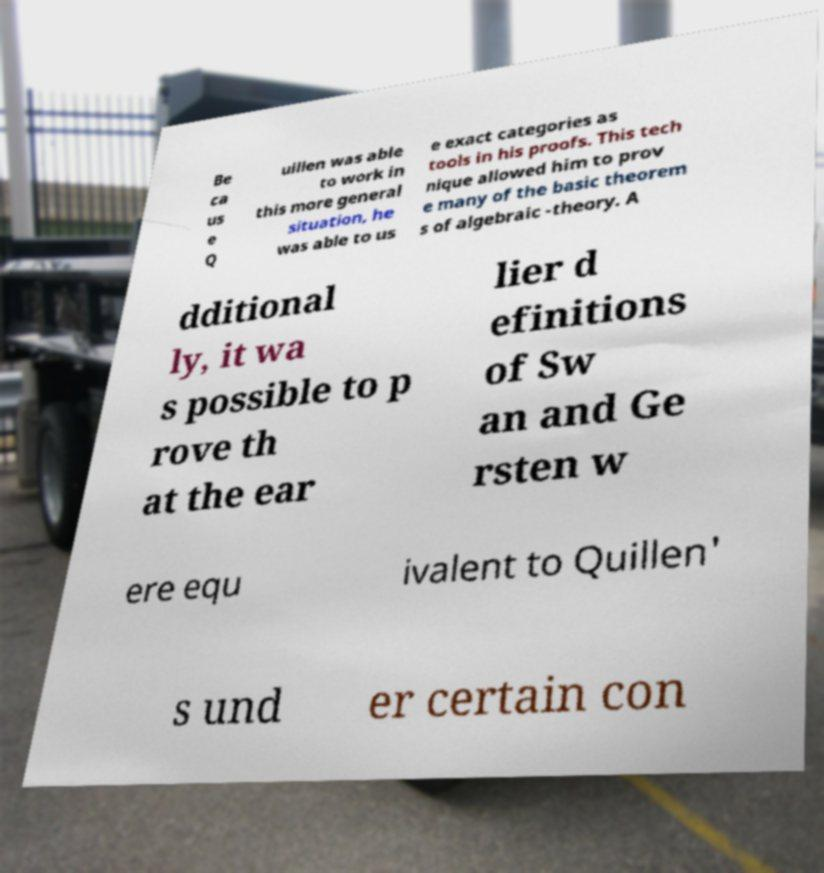Please identify and transcribe the text found in this image. Be ca us e Q uillen was able to work in this more general situation, he was able to us e exact categories as tools in his proofs. This tech nique allowed him to prov e many of the basic theorem s of algebraic -theory. A dditional ly, it wa s possible to p rove th at the ear lier d efinitions of Sw an and Ge rsten w ere equ ivalent to Quillen' s und er certain con 